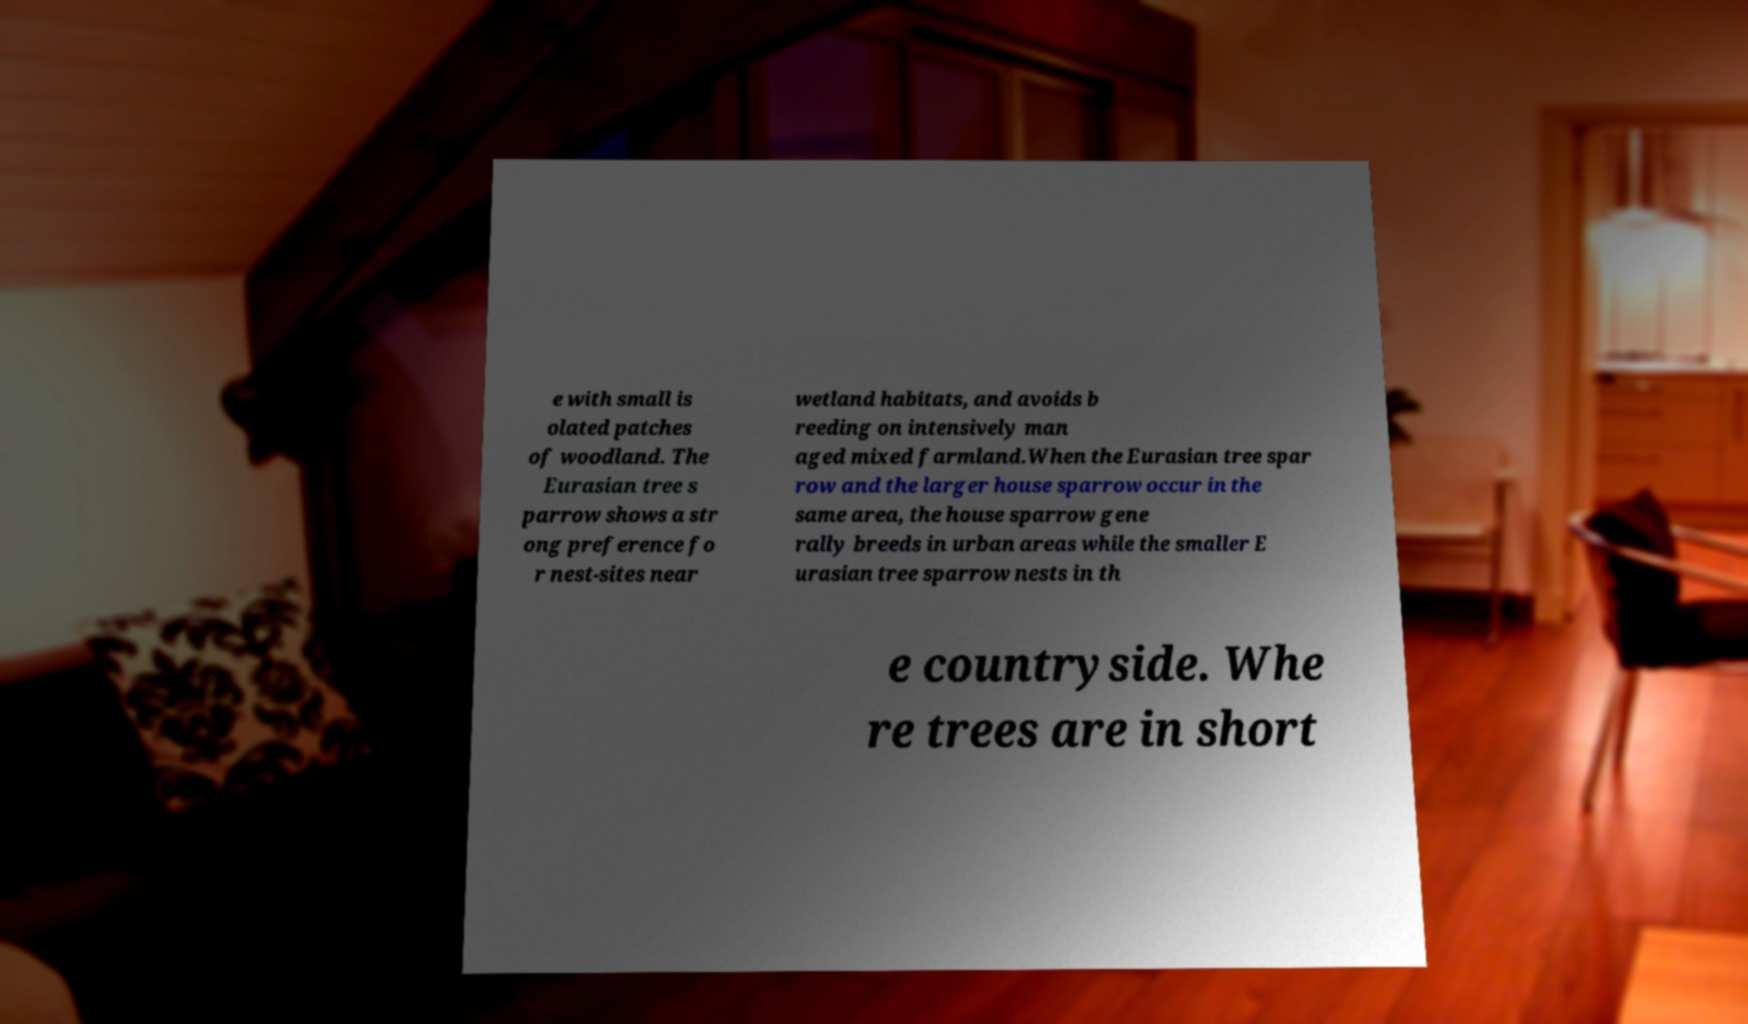Could you assist in decoding the text presented in this image and type it out clearly? e with small is olated patches of woodland. The Eurasian tree s parrow shows a str ong preference fo r nest-sites near wetland habitats, and avoids b reeding on intensively man aged mixed farmland.When the Eurasian tree spar row and the larger house sparrow occur in the same area, the house sparrow gene rally breeds in urban areas while the smaller E urasian tree sparrow nests in th e countryside. Whe re trees are in short 